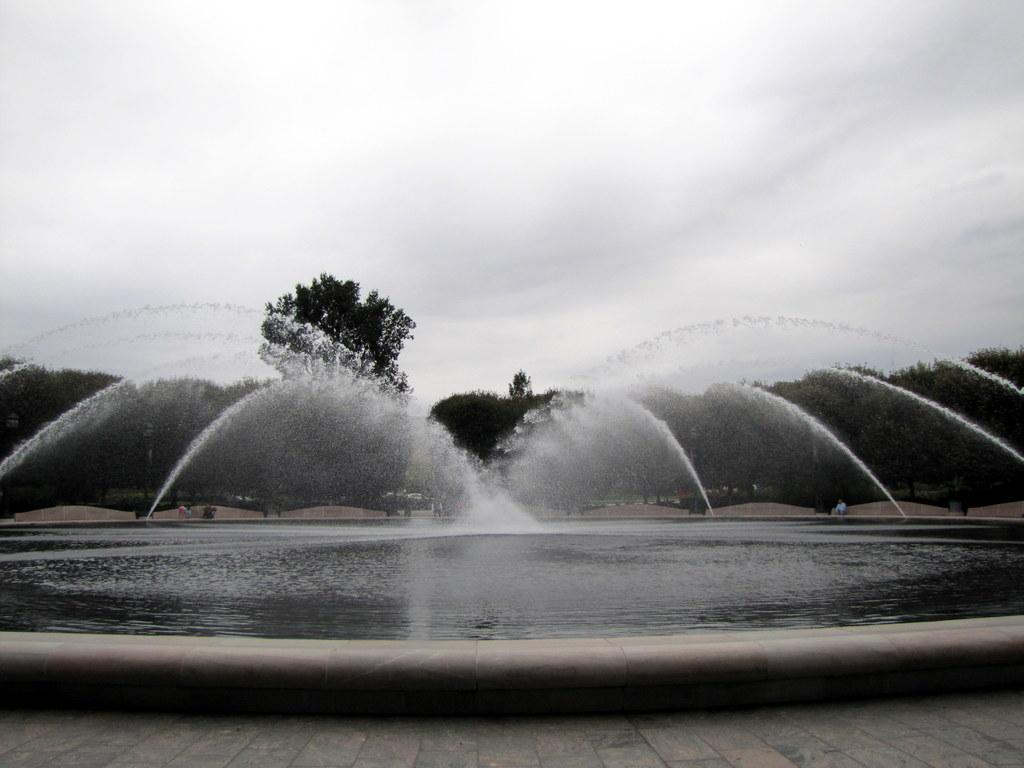What is the main subject in the middle of the image? There is a water fountain in the middle of the image. What can be seen in the background of the image? There are people and trees in the background of the image. What is visible at the top of the image? The sky is visible at the top of the image. What invention is being demonstrated in the image? There is no invention being demonstrated in the image; it features a water fountain, people, trees, and the sky. 